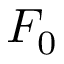Convert formula to latex. <formula><loc_0><loc_0><loc_500><loc_500>F _ { 0 }</formula> 